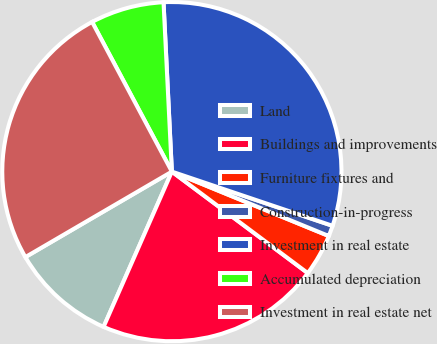Convert chart to OTSL. <chart><loc_0><loc_0><loc_500><loc_500><pie_chart><fcel>Land<fcel>Buildings and improvements<fcel>Furniture fixtures and<fcel>Construction-in-progress<fcel>Investment in real estate<fcel>Accumulated depreciation<fcel>Investment in real estate net<nl><fcel>10.0%<fcel>21.39%<fcel>4.01%<fcel>1.02%<fcel>30.96%<fcel>7.01%<fcel>25.61%<nl></chart> 